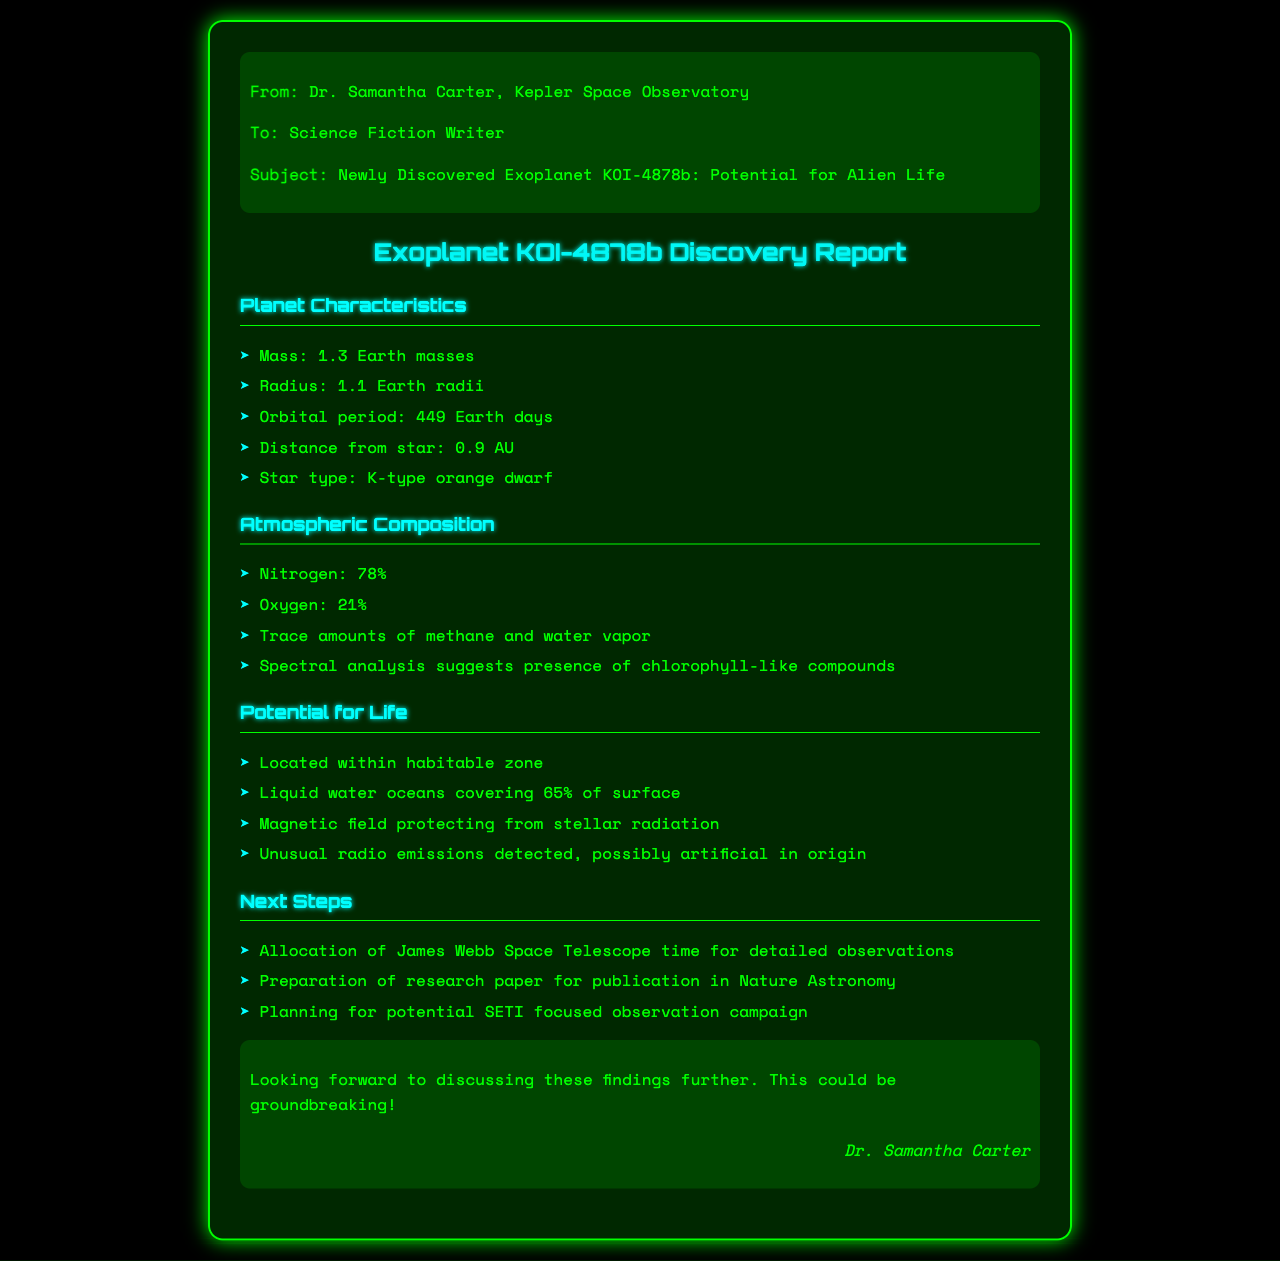what is the mass of KOI-4878b? The mass of KOI-4878b is listed precisely in the document under Planet Characteristics.
Answer: 1.3 Earth masses what is the radius of KOI-4878b? The radius is specified in the same section and indicates how large the planet is compared to Earth.
Answer: 1.1 Earth radii how long is KOI-4878b's orbital period? The orbital period provides insight into the planet's distance from its star and rotation schedule, found in the Planet Characteristics section.
Answer: 449 Earth days what percentage of KOI-4878b's surface is covered by liquid water? This detail illustrates the planet's potential for life and is drawn from the Potential for Life section.
Answer: 65% what type of star does KOI-4878b orbit? The type of star is important for understanding the environment of the exoplanet, as specified in the document.
Answer: K-type orange dwarf what compounds are suggested to exist in the atmosphere of KOI-4878b? This question looks for specific atmospheric elements that may hint at life, found in the Atmospheric Composition section.
Answer: Chlorophyll-like compounds what is the next step for observing KOI-4878b? The steps for further research are outlined in the Next Steps section, indicating future plans for the planet.
Answer: Allocating James Webb Space Telescope time what was detected that could be artificial in origin? This involves reasoning about the implications of unusual findings regarding potential life or intelligence on KOI-4878b.
Answer: Unusual radio emissions who sent the fax? Identifying the sender reveals credibility and the context of the findings.
Answer: Dr. Samantha Carter 